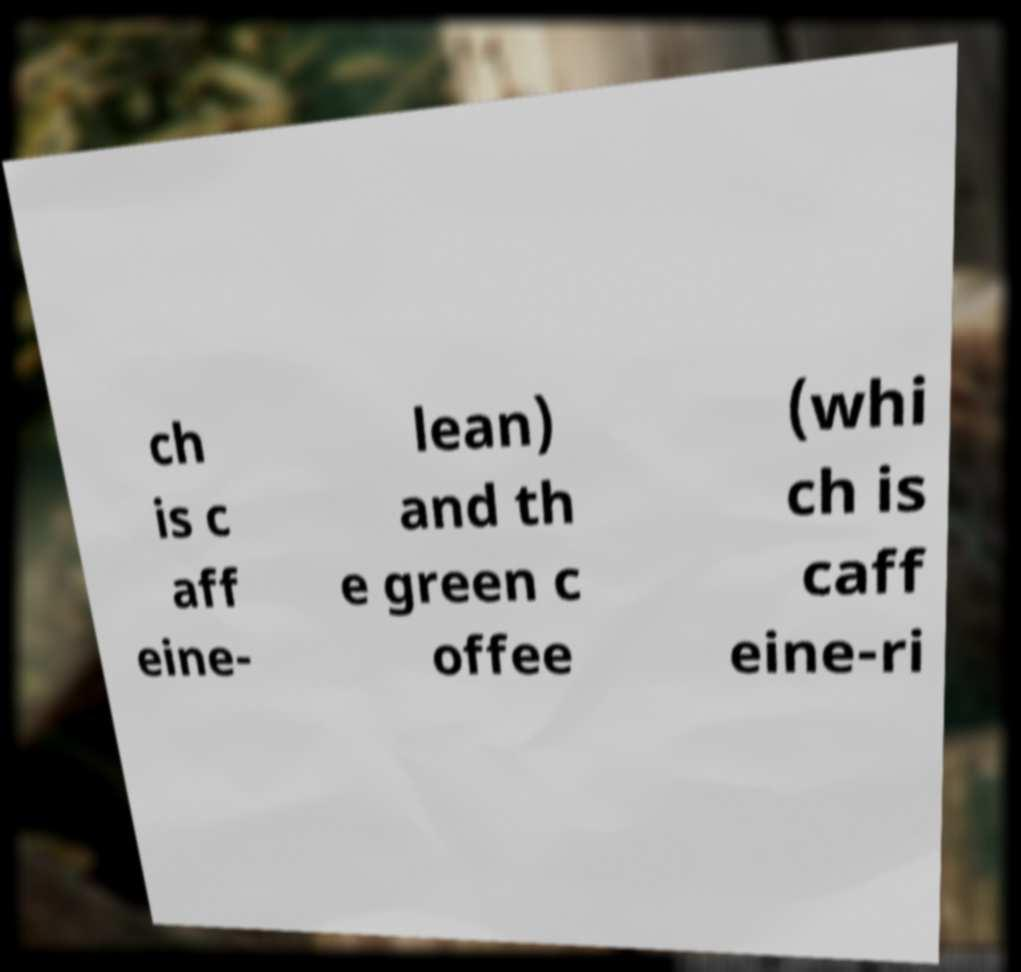Could you assist in decoding the text presented in this image and type it out clearly? ch is c aff eine- lean) and th e green c offee (whi ch is caff eine-ri 